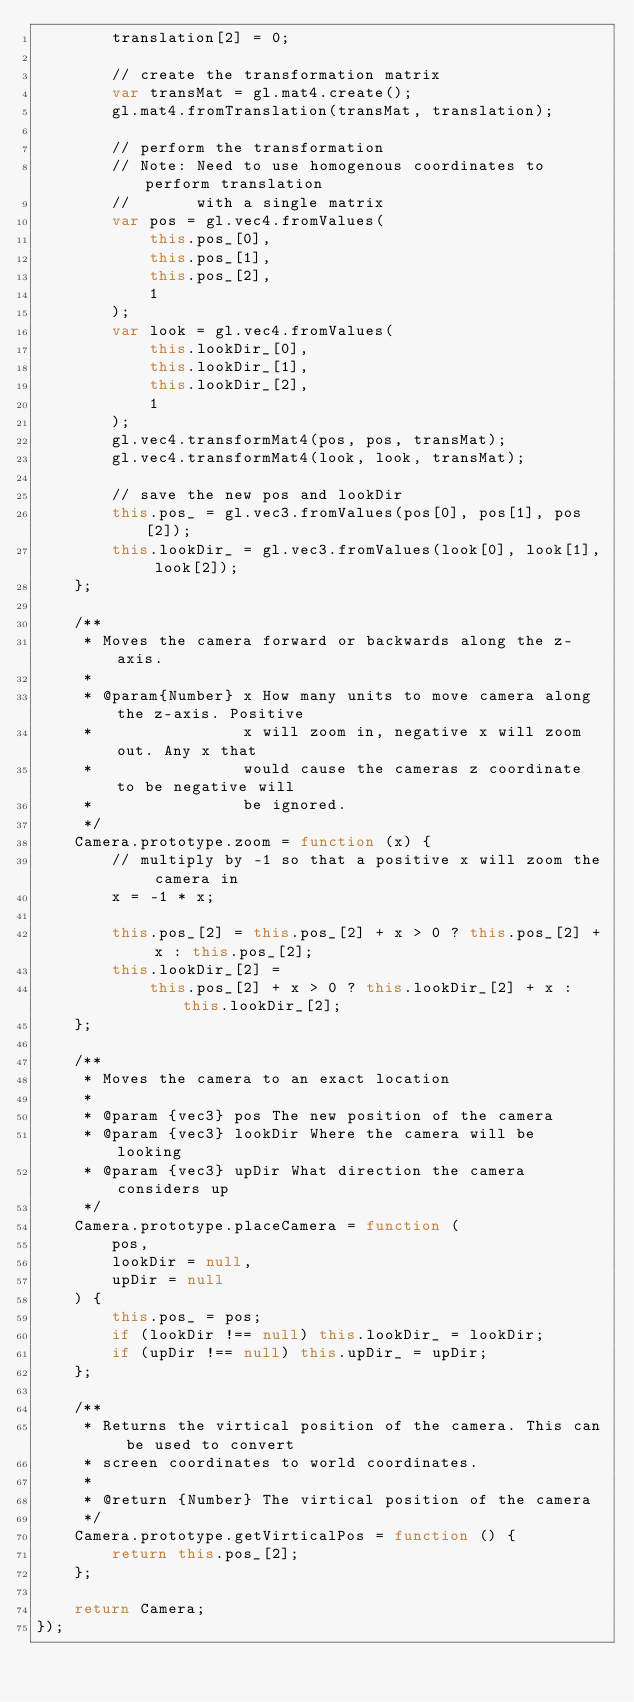<code> <loc_0><loc_0><loc_500><loc_500><_JavaScript_>        translation[2] = 0;

        // create the transformation matrix
        var transMat = gl.mat4.create();
        gl.mat4.fromTranslation(transMat, translation);

        // perform the transformation
        // Note: Need to use homogenous coordinates to perform translation
        //       with a single matrix
        var pos = gl.vec4.fromValues(
            this.pos_[0],
            this.pos_[1],
            this.pos_[2],
            1
        );
        var look = gl.vec4.fromValues(
            this.lookDir_[0],
            this.lookDir_[1],
            this.lookDir_[2],
            1
        );
        gl.vec4.transformMat4(pos, pos, transMat);
        gl.vec4.transformMat4(look, look, transMat);

        // save the new pos and lookDir
        this.pos_ = gl.vec3.fromValues(pos[0], pos[1], pos[2]);
        this.lookDir_ = gl.vec3.fromValues(look[0], look[1], look[2]);
    };

    /**
     * Moves the camera forward or backwards along the z-axis.
     *
     * @param{Number} x How many units to move camera along the z-axis. Positive
     *                x will zoom in, negative x will zoom out. Any x that
     *                would cause the cameras z coordinate to be negative will
     *                be ignored.
     */
    Camera.prototype.zoom = function (x) {
        // multiply by -1 so that a positive x will zoom the camera in
        x = -1 * x;

        this.pos_[2] = this.pos_[2] + x > 0 ? this.pos_[2] + x : this.pos_[2];
        this.lookDir_[2] =
            this.pos_[2] + x > 0 ? this.lookDir_[2] + x : this.lookDir_[2];
    };

    /**
     * Moves the camera to an exact location
     *
     * @param {vec3} pos The new position of the camera
     * @param {vec3} lookDir Where the camera will be looking
     * @param {vec3} upDir What direction the camera considers up
     */
    Camera.prototype.placeCamera = function (
        pos,
        lookDir = null,
        upDir = null
    ) {
        this.pos_ = pos;
        if (lookDir !== null) this.lookDir_ = lookDir;
        if (upDir !== null) this.upDir_ = upDir;
    };

    /**
     * Returns the virtical position of the camera. This can be used to convert
     * screen coordinates to world coordinates.
     *
     * @return {Number} The virtical position of the camera
     */
    Camera.prototype.getVirticalPos = function () {
        return this.pos_[2];
    };

    return Camera;
});
</code> 